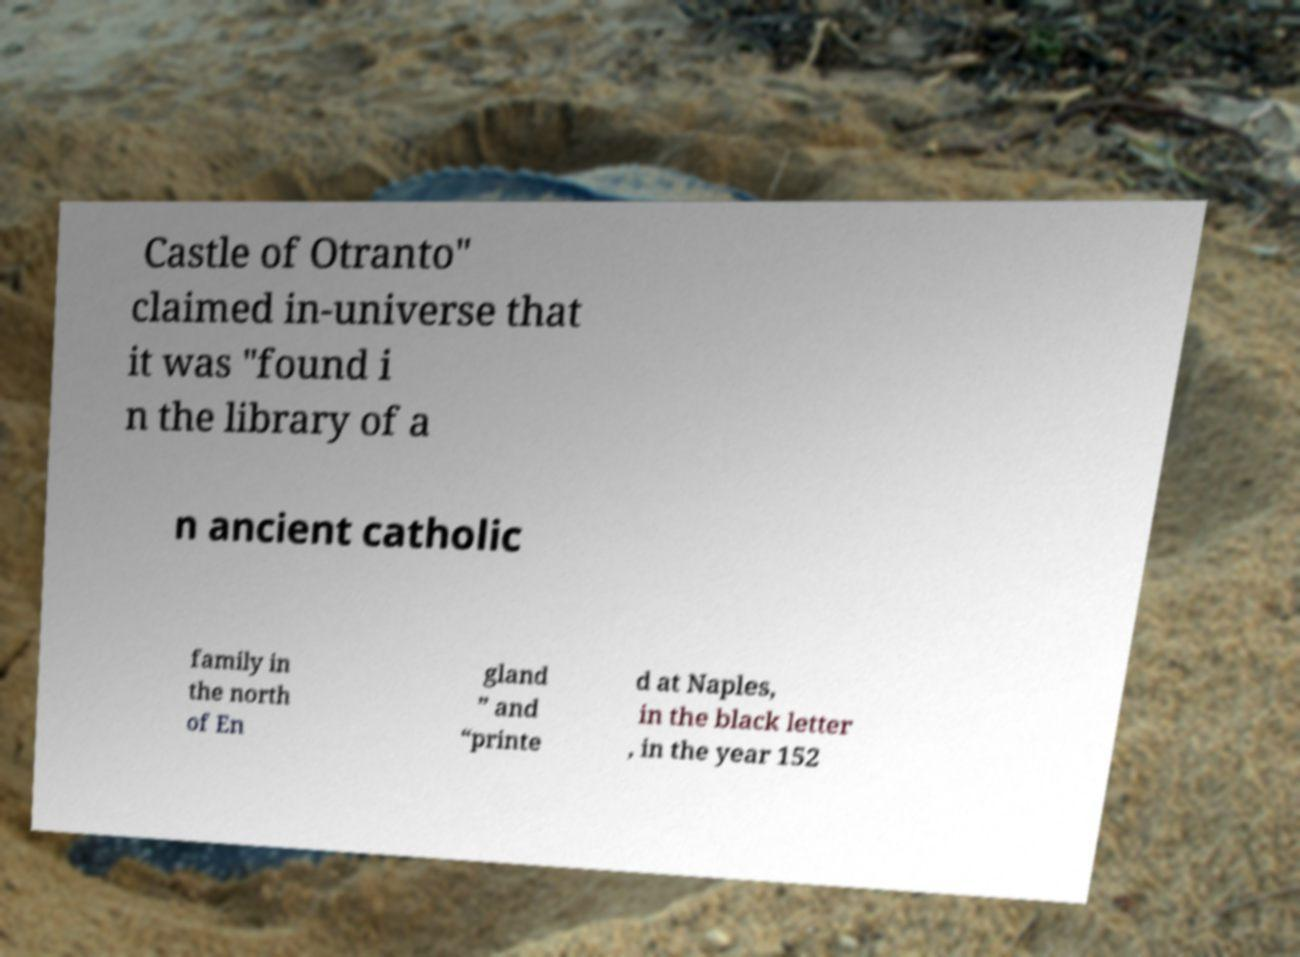I need the written content from this picture converted into text. Can you do that? Castle of Otranto" claimed in-universe that it was "found i n the library of a n ancient catholic family in the north of En gland ” and “printe d at Naples, in the black letter , in the year 152 